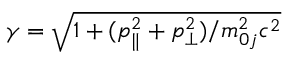<formula> <loc_0><loc_0><loc_500><loc_500>\gamma = \sqrt { 1 + ( p _ { \| } ^ { 2 } + p _ { \perp } ^ { 2 } ) / m _ { 0 j } ^ { 2 } c ^ { 2 } }</formula> 